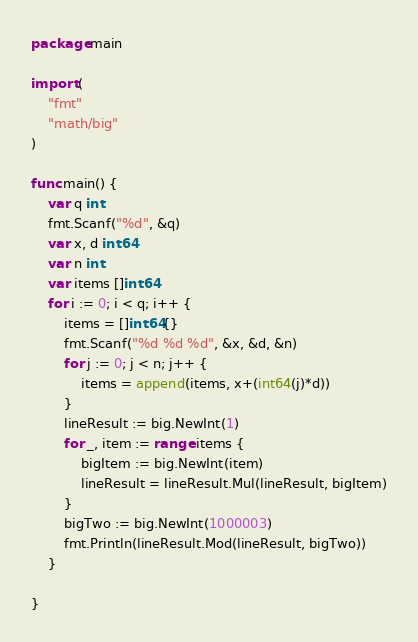Convert code to text. <code><loc_0><loc_0><loc_500><loc_500><_Go_>package main

import (
	"fmt"
	"math/big"
)

func main() {
	var q int
	fmt.Scanf("%d", &q)
	var x, d int64
	var n int
	var items []int64
	for i := 0; i < q; i++ {
		items = []int64{}
		fmt.Scanf("%d %d %d", &x, &d, &n)
		for j := 0; j < n; j++ {
			items = append(items, x+(int64(j)*d))
		}
		lineResult := big.NewInt(1)
		for _, item := range items {
			bigItem := big.NewInt(item)
			lineResult = lineResult.Mul(lineResult, bigItem)
		}
		bigTwo := big.NewInt(1000003)
		fmt.Println(lineResult.Mod(lineResult, bigTwo))
	}

}
</code> 